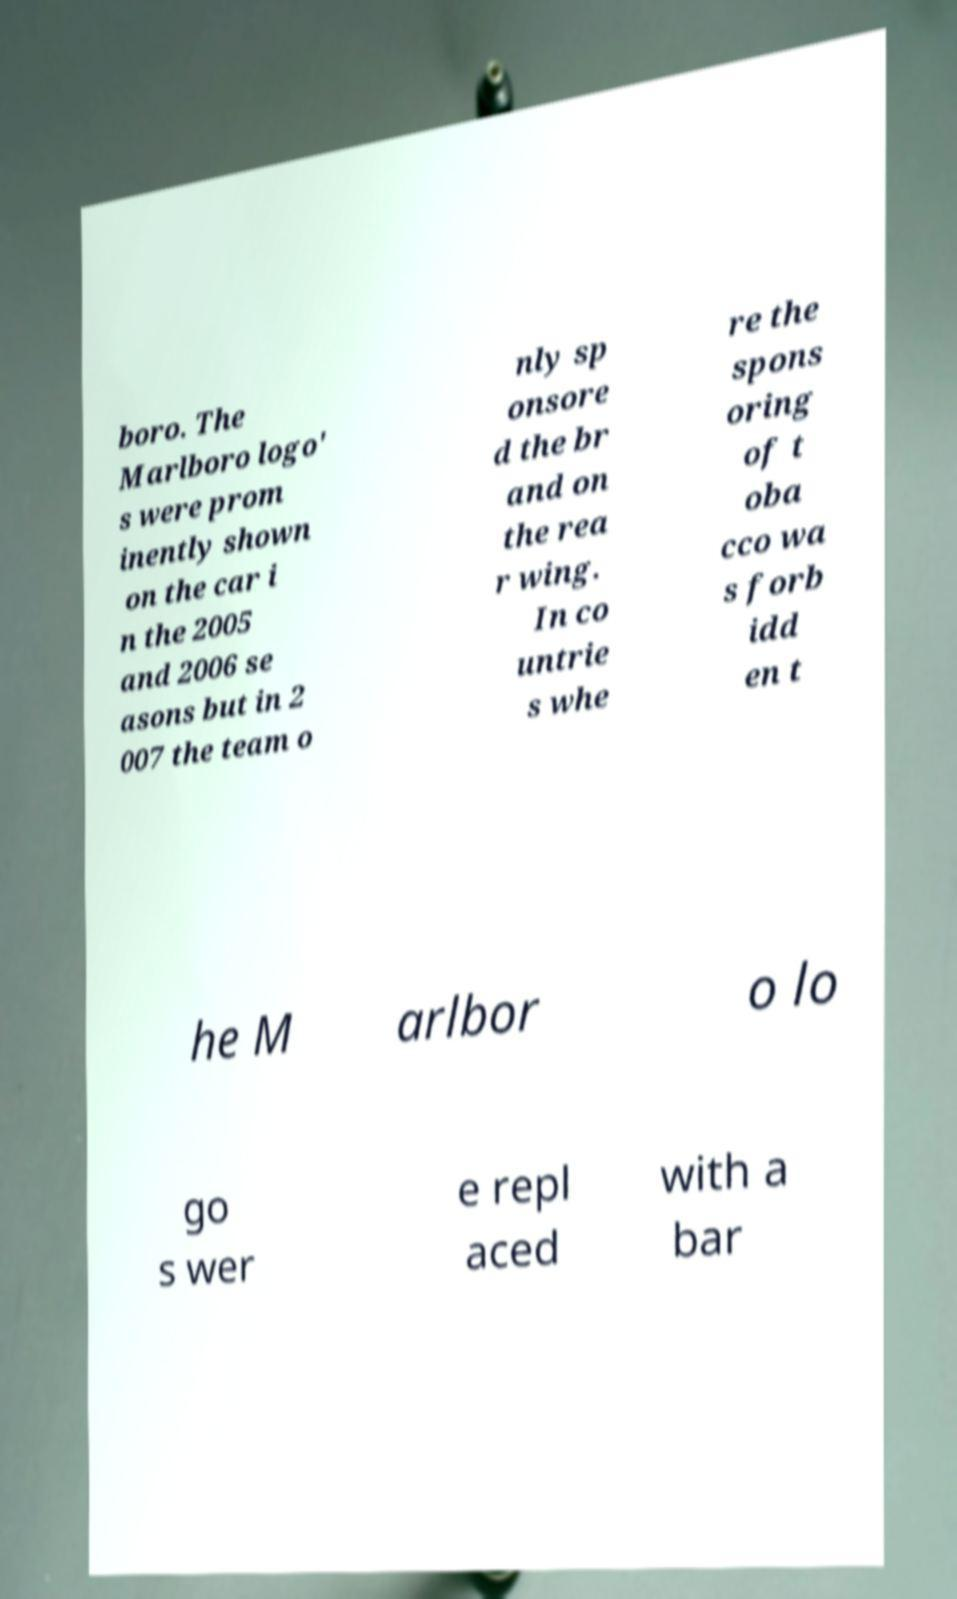Could you extract and type out the text from this image? boro. The Marlboro logo' s were prom inently shown on the car i n the 2005 and 2006 se asons but in 2 007 the team o nly sp onsore d the br and on the rea r wing. In co untrie s whe re the spons oring of t oba cco wa s forb idd en t he M arlbor o lo go s wer e repl aced with a bar 